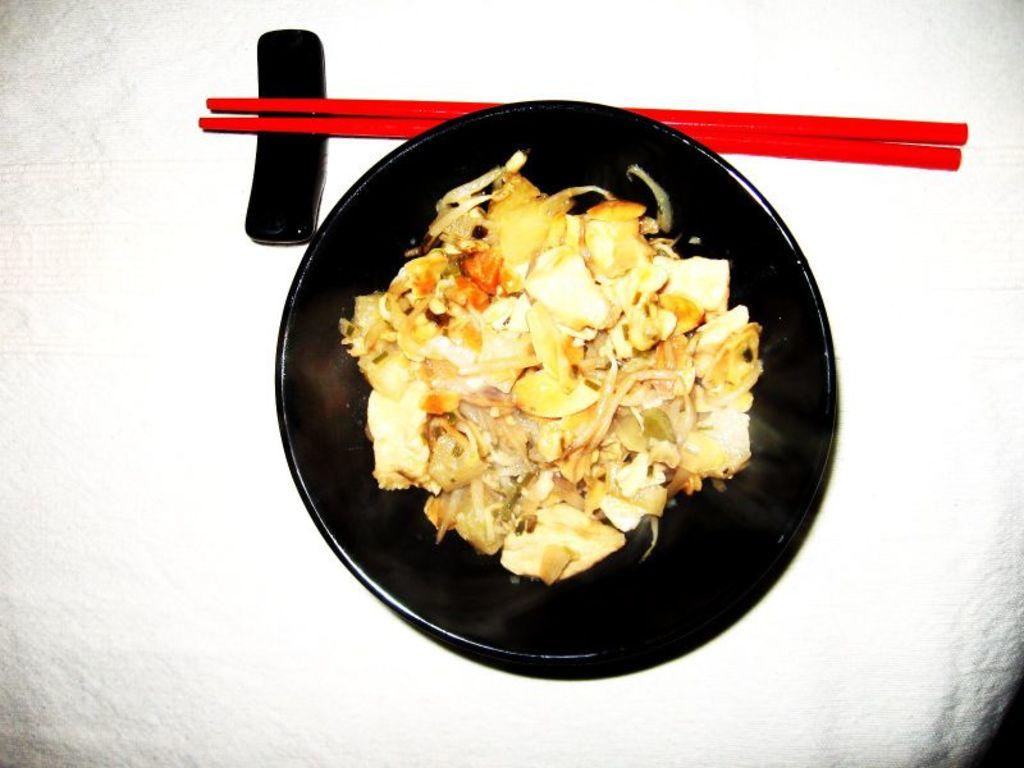What type of table is in the image? There is a white table in the image. What is placed on the table? There is a plate on the table. What is on the plate? Food is placed on the plate. What utensil is beside the plate? There are chopsticks beside the plate. What is near the plate and chopsticks? There is a holder near the plate and chopsticks. What type of celery is being requested by the person in the image? There is no person present in the image, and therefore no request for celery can be observed. 